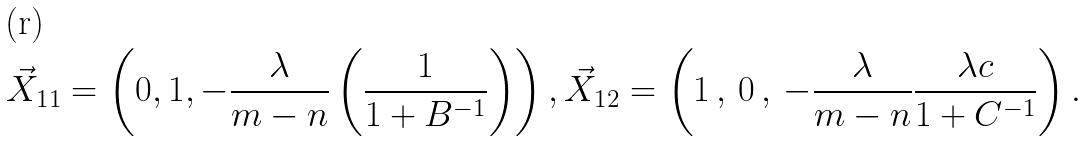Convert formula to latex. <formula><loc_0><loc_0><loc_500><loc_500>\vec { X } _ { 1 1 } & = \left ( 0 , 1 , - \frac { \lambda } { m - n } \left ( \frac { 1 } { 1 + B ^ { - 1 } } \right ) \right ) , \vec { X } _ { 1 2 } = \left ( 1 \, , \, 0 \, , \, - \frac { \lambda } { m - n } \frac { \lambda c } { 1 + C ^ { - 1 } } \right ) .</formula> 